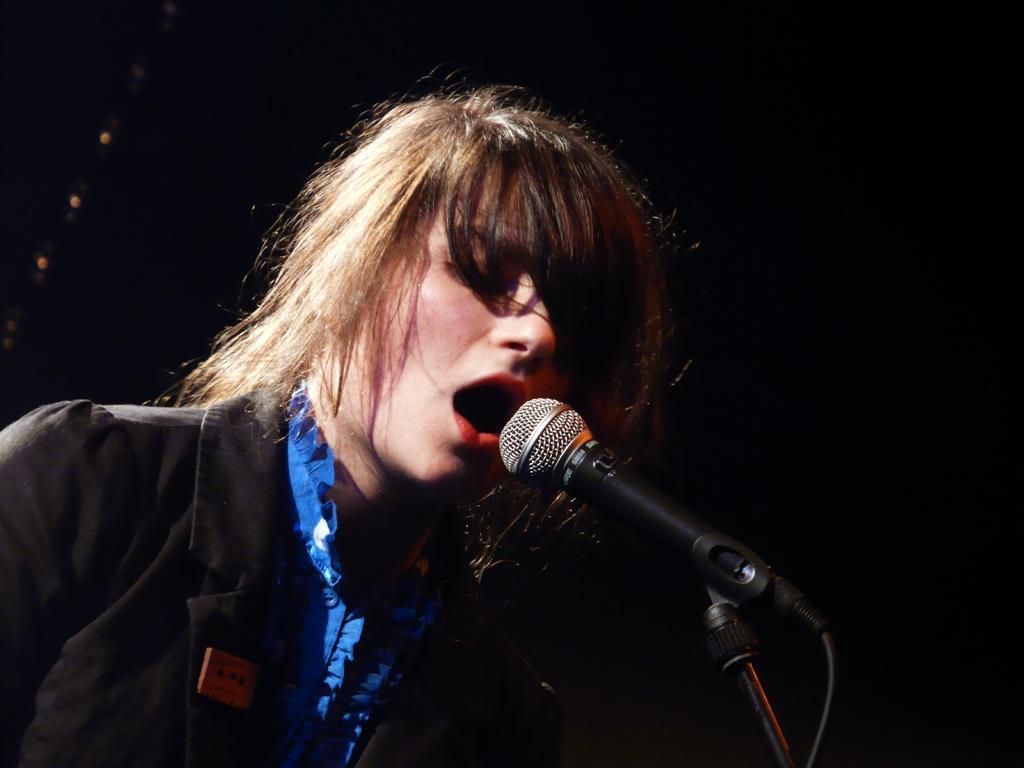Can you describe this image briefly? In this picture we can see a person here, there is a microphone in front of person, we can see a dark background. 